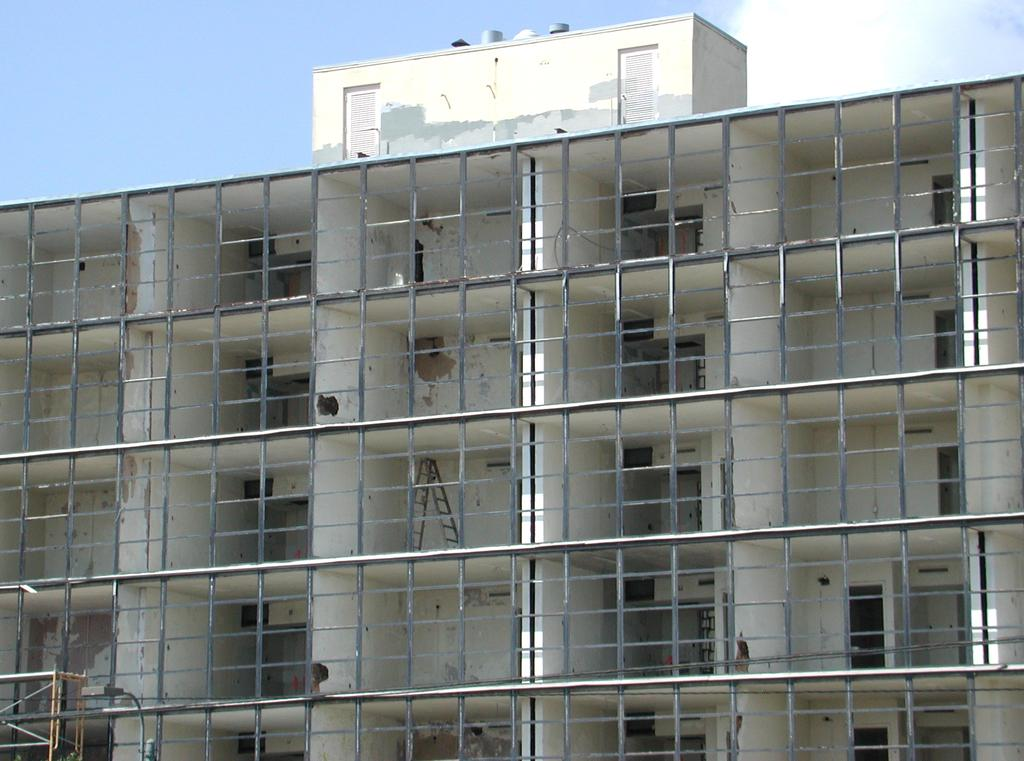Where was the picture taken? The picture was clicked outside. What can be seen in the foreground of the image? There is a building, metal rods, and a ladder in the foreground of the image. What is visible in the background of the image? The sky is visible in the background of the image. What type of ring can be seen on the ladder in the image? There is no ring present on the ladder in the image. What street is visible in the background of the image? The image does not show a street; it only shows a building, metal rods, a ladder, and the sky in the background. 